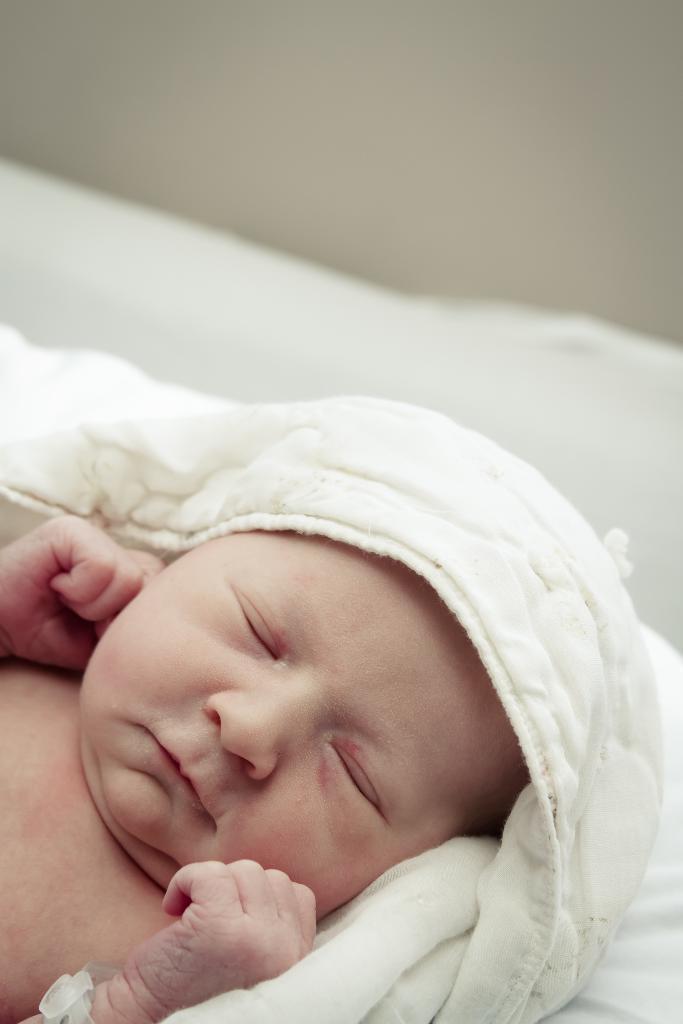Could you give a brief overview of what you see in this image? In this picture there is a baby and a blanket. The background is blurred. 